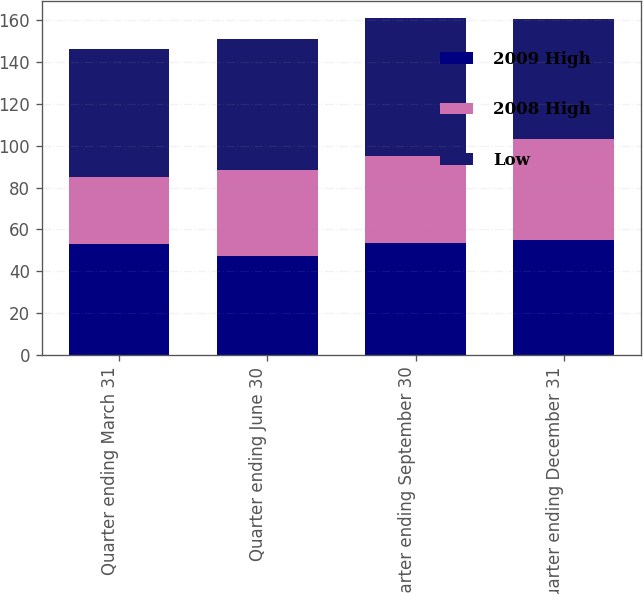Convert chart to OTSL. <chart><loc_0><loc_0><loc_500><loc_500><stacked_bar_chart><ecel><fcel>Quarter ending March 31<fcel>Quarter ending June 30<fcel>Quarter ending September 30<fcel>Quarter ending December 31<nl><fcel>2009 High<fcel>53.03<fcel>47.51<fcel>53.46<fcel>55.14<nl><fcel>2008 High<fcel>31.84<fcel>40.82<fcel>41.76<fcel>48.18<nl><fcel>Low<fcel>61.65<fcel>62.67<fcel>66<fcel>57.36<nl></chart> 